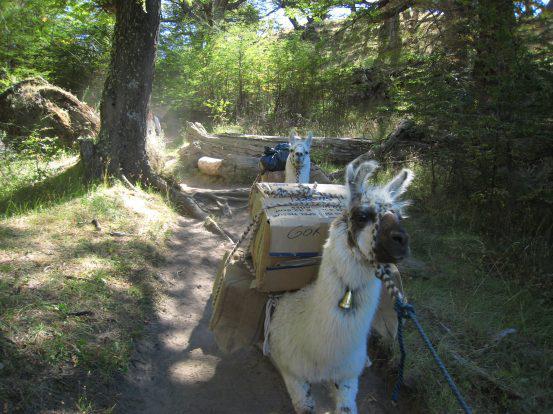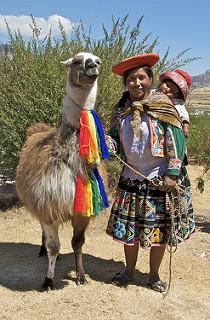The first image is the image on the left, the second image is the image on the right. Considering the images on both sides, is "The left image contains a single llama and a single person." valid? Answer yes or no. No. 